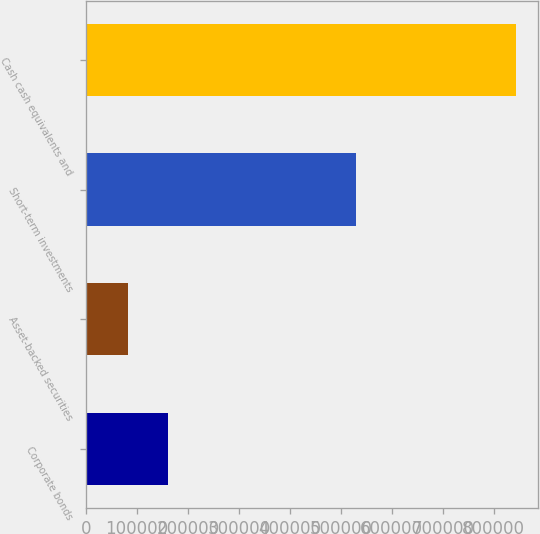Convert chart to OTSL. <chart><loc_0><loc_0><loc_500><loc_500><bar_chart><fcel>Corporate bonds<fcel>Asset-backed securities<fcel>Short-term investments<fcel>Cash cash equivalents and<nl><fcel>160907<fcel>83517<fcel>530467<fcel>844084<nl></chart> 